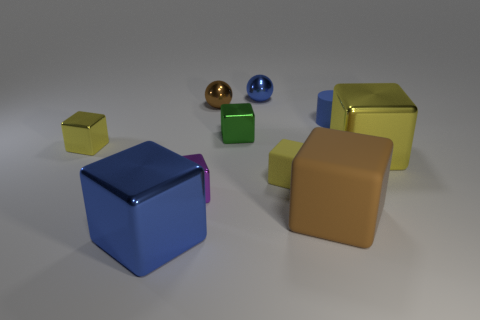Is there a big shiny block that has the same color as the cylinder?
Provide a succinct answer. Yes. There is a blue metal object that is to the right of the small brown thing; is there a tiny object that is behind it?
Your response must be concise. No. Is the size of the purple shiny thing the same as the yellow metal cube that is to the left of the tiny yellow rubber object?
Your response must be concise. Yes. There is a metal object to the left of the shiny thing that is in front of the big matte cube; is there a big brown rubber block that is to the left of it?
Give a very brief answer. No. There is a yellow cube right of the big brown thing; what is its material?
Give a very brief answer. Metal. Is the size of the blue metallic block the same as the purple object?
Your answer should be compact. No. What color is the metallic block that is both on the right side of the purple shiny block and left of the brown rubber thing?
Provide a succinct answer. Green. There is a small yellow thing that is made of the same material as the blue sphere; what is its shape?
Make the answer very short. Cube. What number of big objects are both to the left of the tiny blue metallic thing and behind the large rubber object?
Provide a succinct answer. 0. Are there any brown spheres in front of the tiny yellow matte cube?
Offer a terse response. No. 